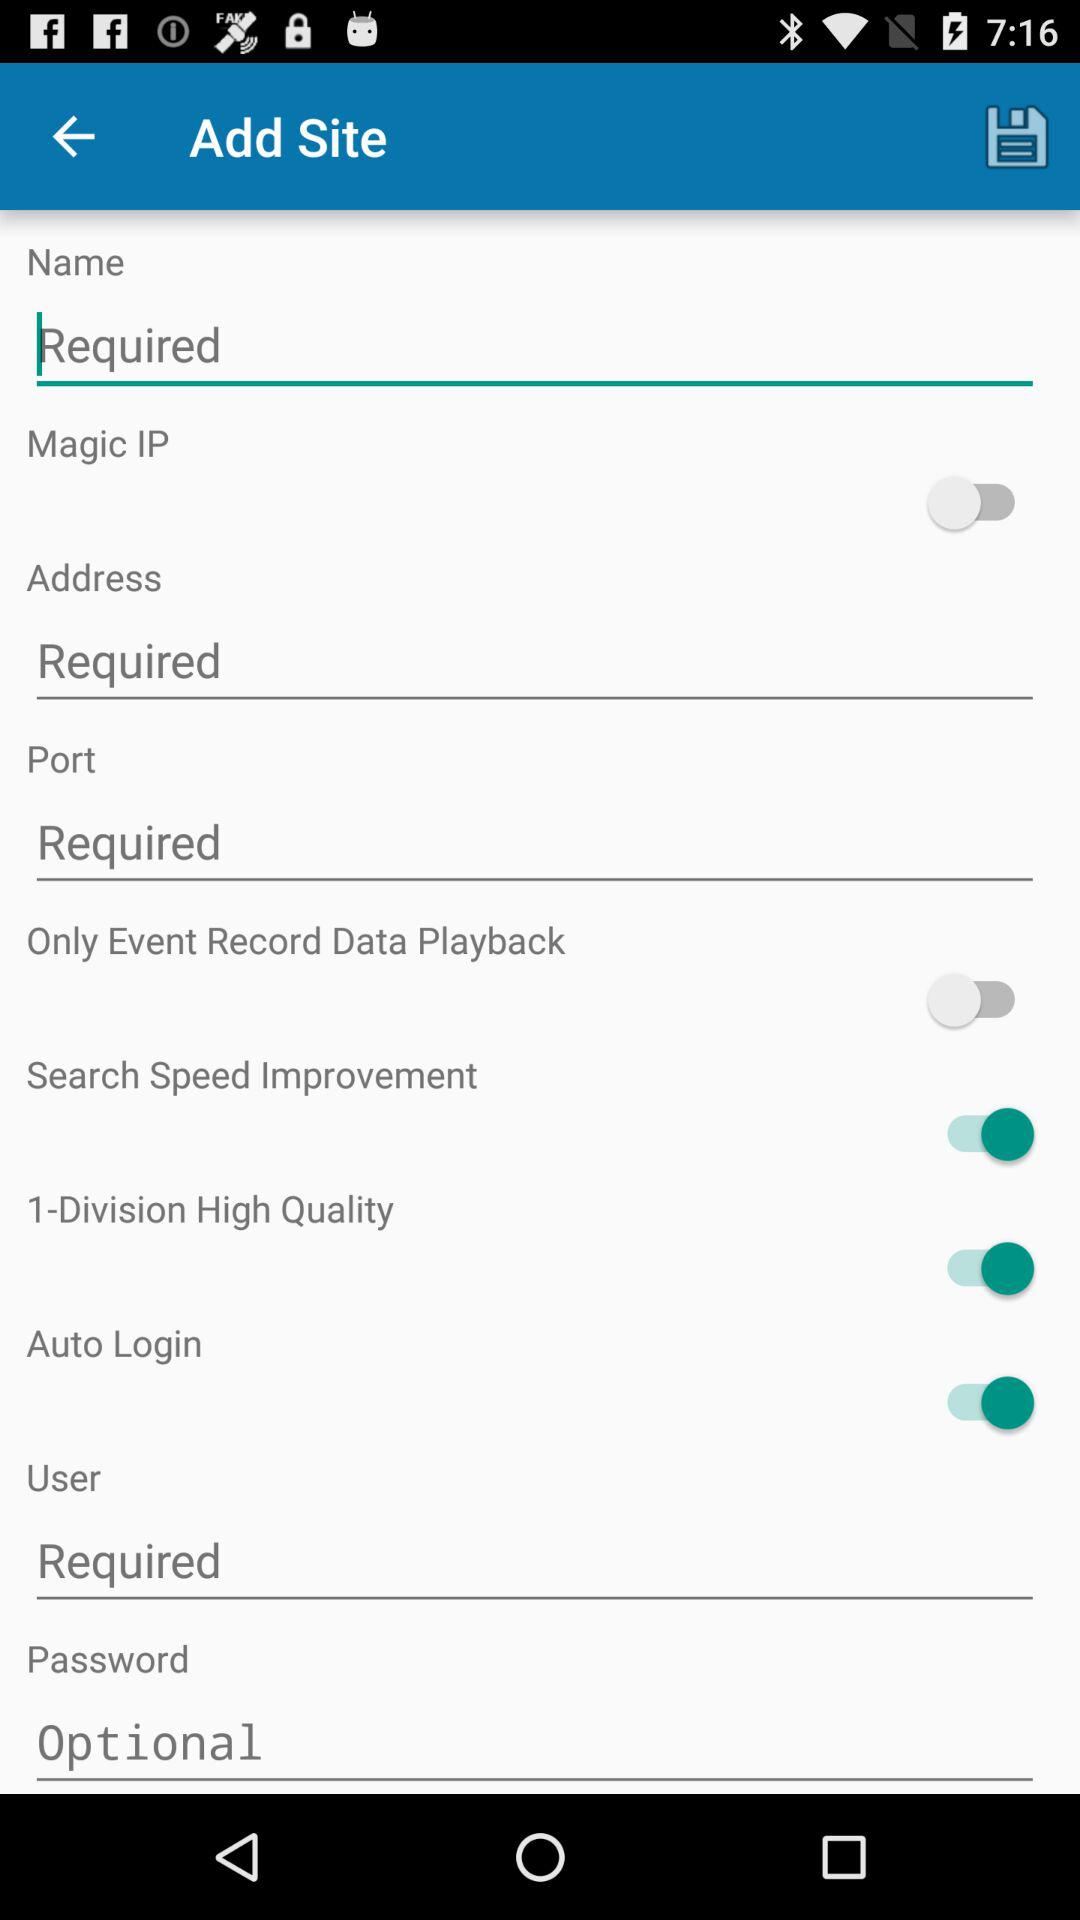What is the status of "Magic IP"? The status is "off". 